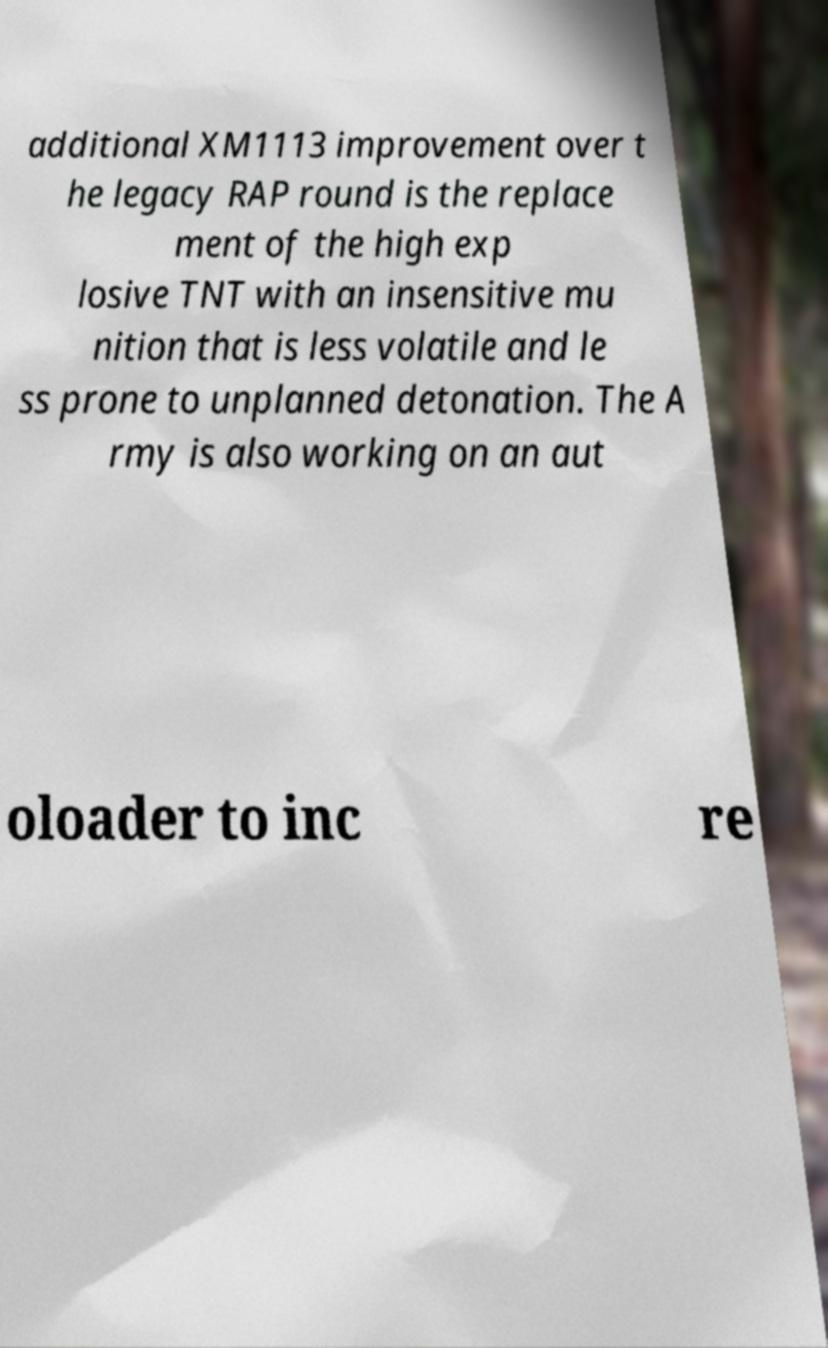Please read and relay the text visible in this image. What does it say? additional XM1113 improvement over t he legacy RAP round is the replace ment of the high exp losive TNT with an insensitive mu nition that is less volatile and le ss prone to unplanned detonation. The A rmy is also working on an aut oloader to inc re 